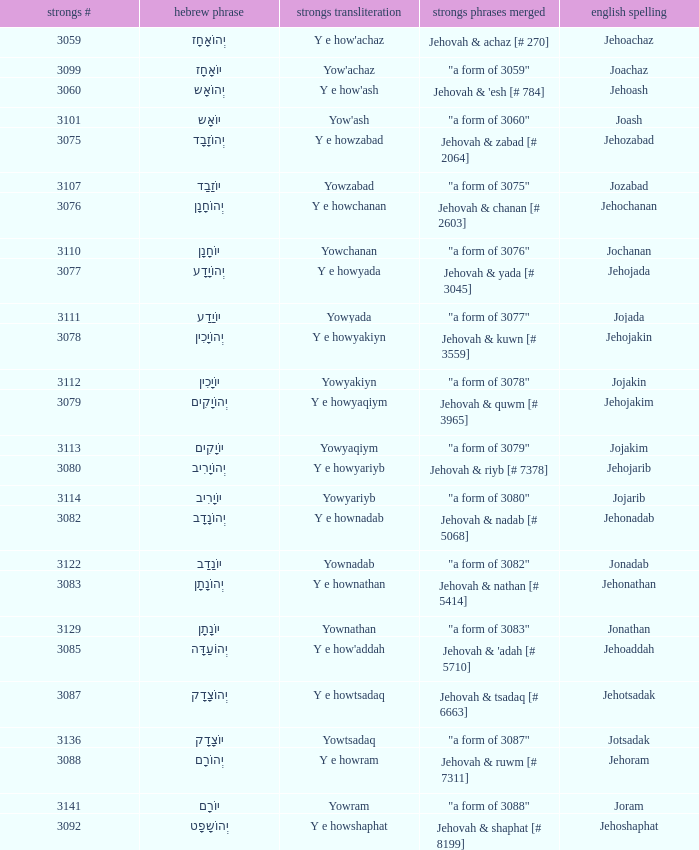How many strongs transliteration of the english spelling of the work jehojakin? 1.0. 